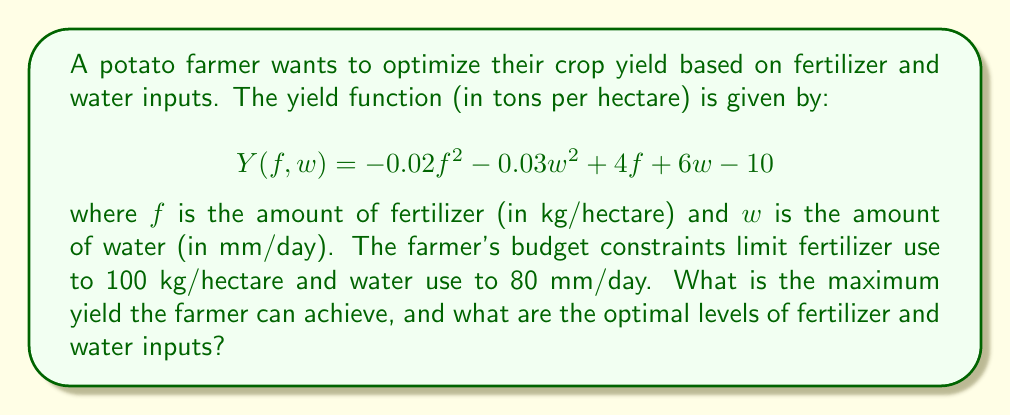Give your solution to this math problem. To solve this optimization problem, we need to follow these steps:

1. Identify the objective function and constraints:
   Objective function: $Y(f,w) = -0.02f^2 - 0.03w^2 + 4f + 6w - 10$
   Constraints: $0 \leq f \leq 100$ and $0 \leq w \leq 80$

2. Find the critical points by taking partial derivatives:
   $$\frac{\partial Y}{\partial f} = -0.04f + 4$$
   $$\frac{\partial Y}{\partial w} = -0.06w + 6$$

3. Set the partial derivatives to zero and solve:
   $-0.04f + 4 = 0$ → $f = 100$
   $-0.06w + 6 = 0$ → $w = 100$

4. Check if the critical point $(100, 100)$ is within the constraints:
   $f = 100$ is at the upper bound, but $w = 100$ exceeds the constraint.

5. Since the unconstrained maximum exceeds the water constraint, we need to check the boundaries:
   a. $f = 100, w = 80$
   b. $f = 100, w = 0$
   c. $f = 0, w = 80$
   d. $f = 0, w = 0$

6. Evaluate the yield function at these points:
   a. $Y(100, 80) = -0.02(100)^2 - 0.03(80)^2 + 4(100) + 6(80) - 10 = 470$
   b. $Y(100, 0) = -0.02(100)^2 + 4(100) - 10 = 190$
   c. $Y(0, 80) = -0.03(80)^2 + 6(80) - 10 = 298$
   d. $Y(0, 0) = -10$

7. The maximum yield is achieved at point (a), where $f = 100$ and $w = 80$.

Therefore, the maximum yield is 470 tons per hectare, achieved with 100 kg/hectare of fertilizer and 80 mm/day of water.
Answer: Maximum yield: 470 tons per hectare
Optimal fertilizer input: 100 kg/hectare
Optimal water input: 80 mm/day 